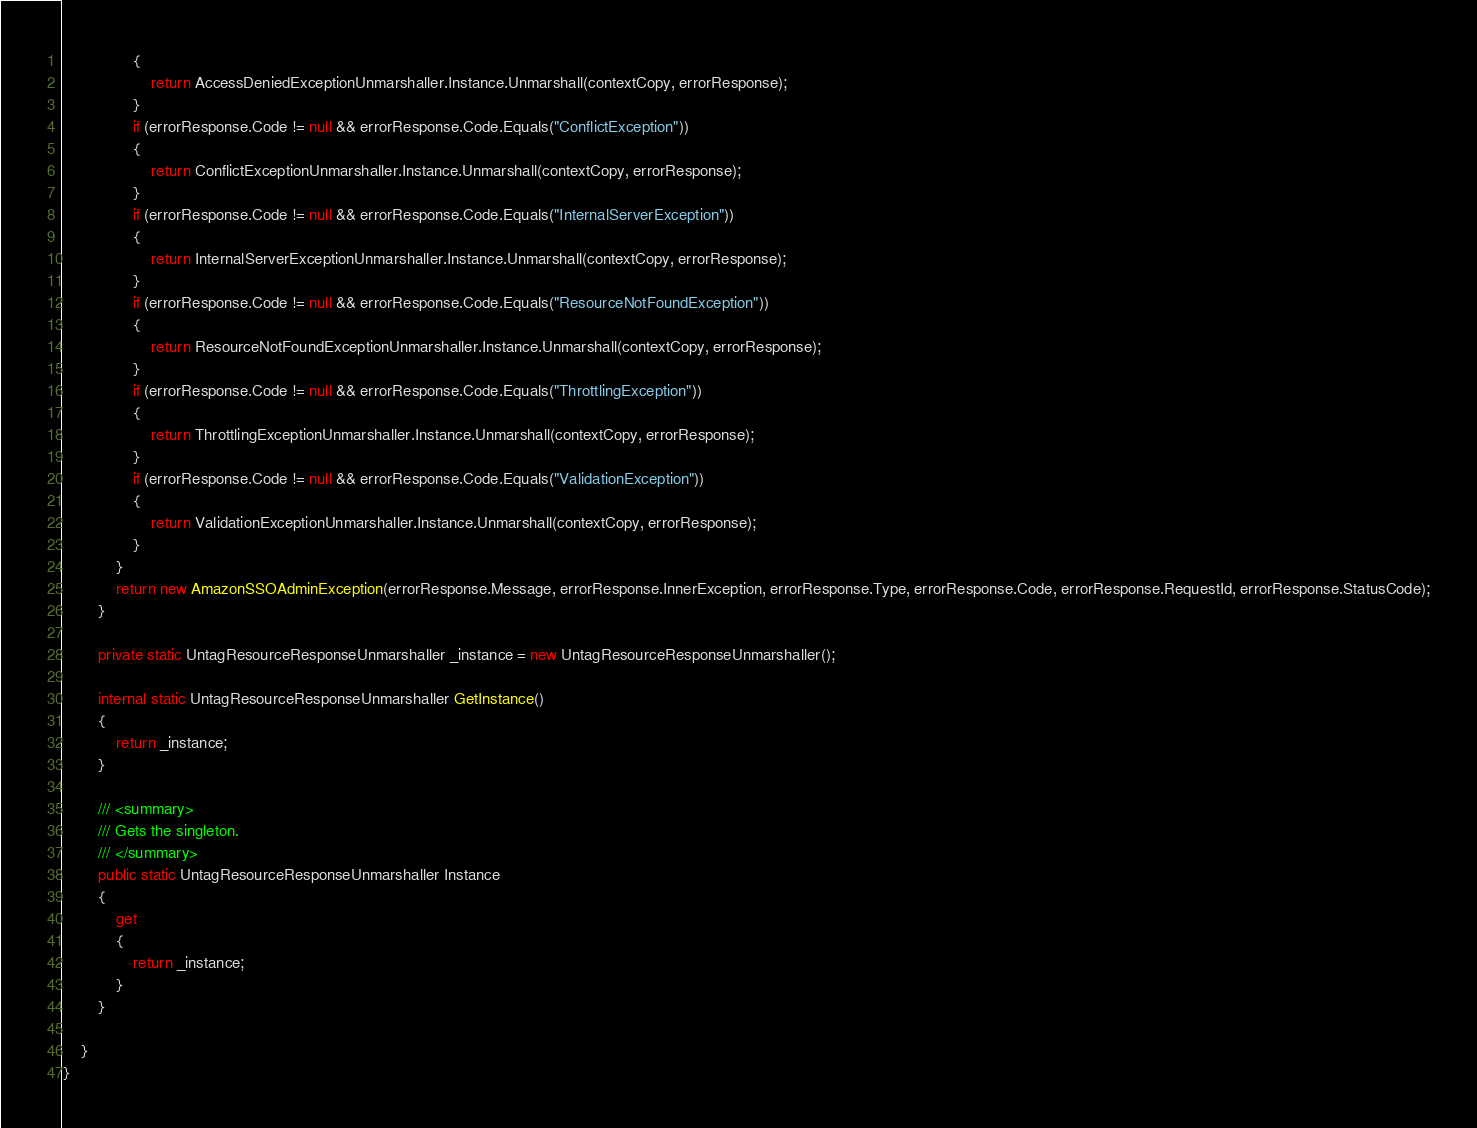Convert code to text. <code><loc_0><loc_0><loc_500><loc_500><_C#_>                {
                    return AccessDeniedExceptionUnmarshaller.Instance.Unmarshall(contextCopy, errorResponse);
                }
                if (errorResponse.Code != null && errorResponse.Code.Equals("ConflictException"))
                {
                    return ConflictExceptionUnmarshaller.Instance.Unmarshall(contextCopy, errorResponse);
                }
                if (errorResponse.Code != null && errorResponse.Code.Equals("InternalServerException"))
                {
                    return InternalServerExceptionUnmarshaller.Instance.Unmarshall(contextCopy, errorResponse);
                }
                if (errorResponse.Code != null && errorResponse.Code.Equals("ResourceNotFoundException"))
                {
                    return ResourceNotFoundExceptionUnmarshaller.Instance.Unmarshall(contextCopy, errorResponse);
                }
                if (errorResponse.Code != null && errorResponse.Code.Equals("ThrottlingException"))
                {
                    return ThrottlingExceptionUnmarshaller.Instance.Unmarshall(contextCopy, errorResponse);
                }
                if (errorResponse.Code != null && errorResponse.Code.Equals("ValidationException"))
                {
                    return ValidationExceptionUnmarshaller.Instance.Unmarshall(contextCopy, errorResponse);
                }
            }
            return new AmazonSSOAdminException(errorResponse.Message, errorResponse.InnerException, errorResponse.Type, errorResponse.Code, errorResponse.RequestId, errorResponse.StatusCode);
        }

        private static UntagResourceResponseUnmarshaller _instance = new UntagResourceResponseUnmarshaller();        

        internal static UntagResourceResponseUnmarshaller GetInstance()
        {
            return _instance;
        }

        /// <summary>
        /// Gets the singleton.
        /// </summary>  
        public static UntagResourceResponseUnmarshaller Instance
        {
            get
            {
                return _instance;
            }
        }

    }
}</code> 